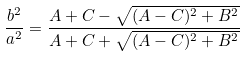Convert formula to latex. <formula><loc_0><loc_0><loc_500><loc_500>\frac { b ^ { 2 } } { a ^ { 2 } } = \frac { A + C - \sqrt { ( A - C ) ^ { 2 } + B ^ { 2 } } } { A + C + \sqrt { ( A - C ) ^ { 2 } + B ^ { 2 } } }</formula> 